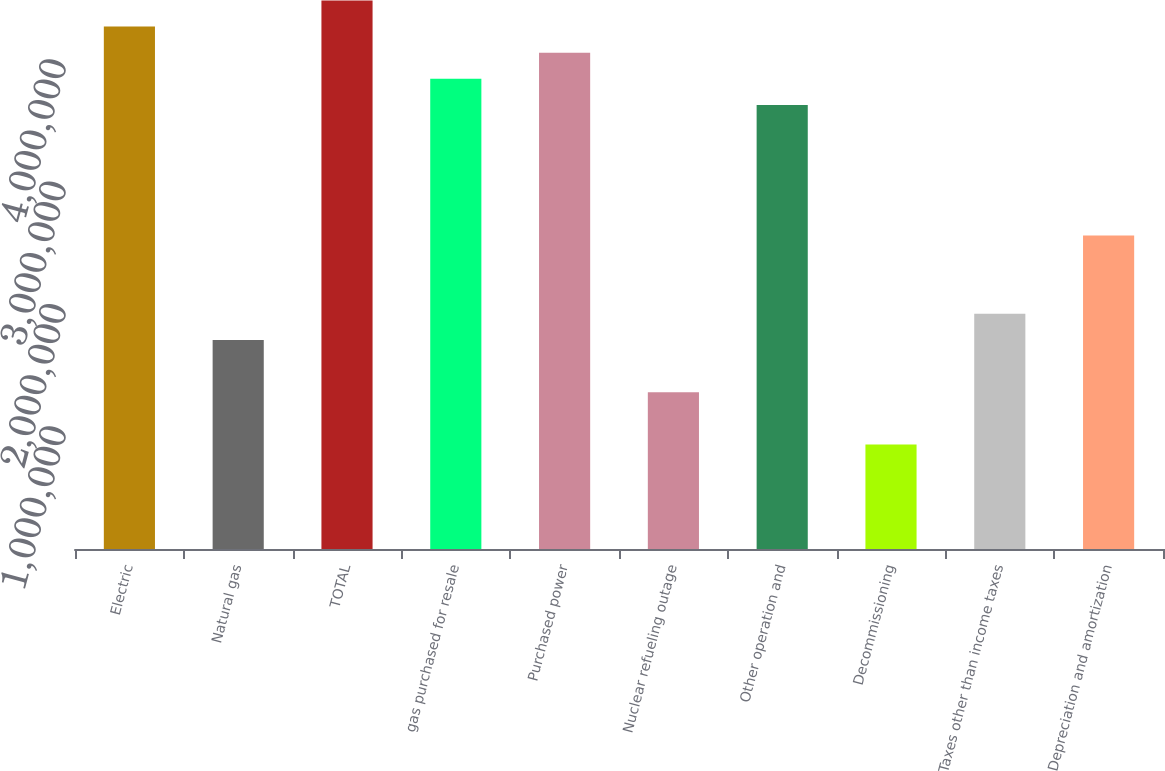<chart> <loc_0><loc_0><loc_500><loc_500><bar_chart><fcel>Electric<fcel>Natural gas<fcel>TOTAL<fcel>gas purchased for resale<fcel>Purchased power<fcel>Nuclear refueling outage<fcel>Other operation and<fcel>Decommissioning<fcel>Taxes other than income taxes<fcel>Depreciation and amortization<nl><fcel>4.26799e+06<fcel>1.70769e+06<fcel>4.48135e+06<fcel>3.84128e+06<fcel>4.05463e+06<fcel>1.28098e+06<fcel>3.62792e+06<fcel>854259<fcel>1.92105e+06<fcel>2.56113e+06<nl></chart> 